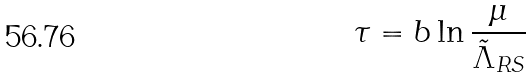Convert formula to latex. <formula><loc_0><loc_0><loc_500><loc_500>\tau = b \ln \frac { \mu } { \tilde { \Lambda } _ { R S } }</formula> 